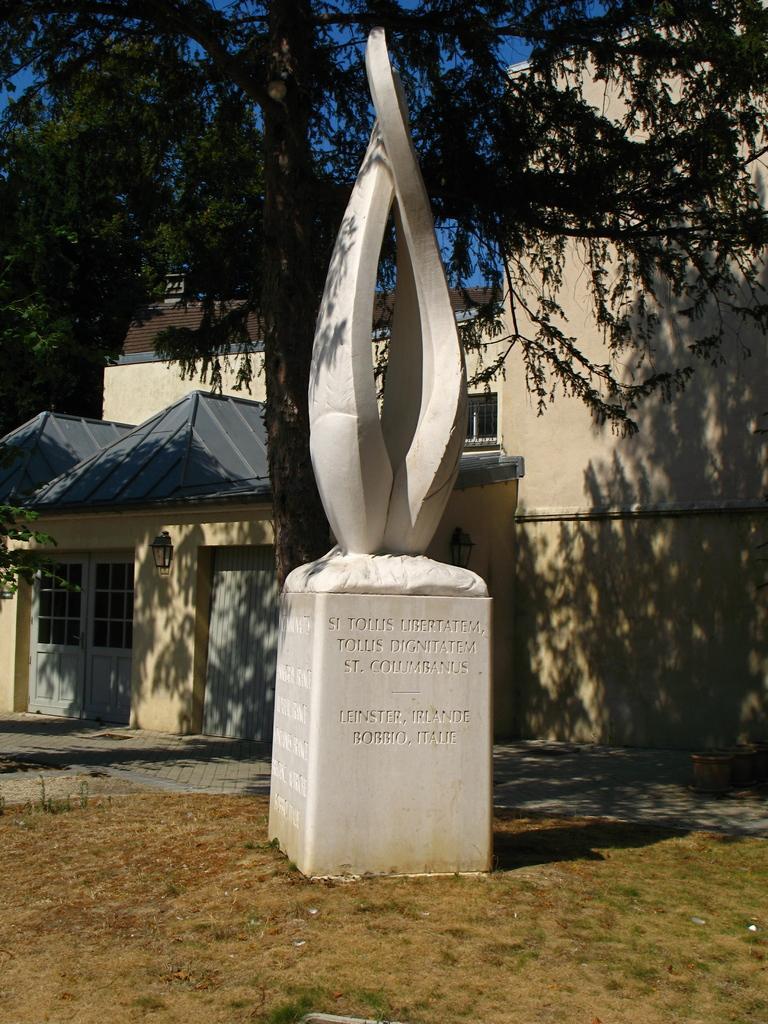How would you summarize this image in a sentence or two? In this image we can a sculpture on a block, there we can see some text on the block, there we can see buildings, grass and a tree. 